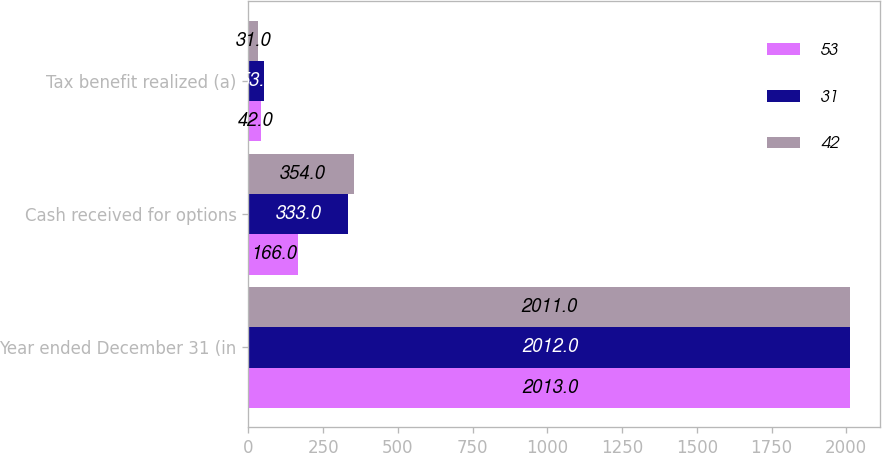Convert chart. <chart><loc_0><loc_0><loc_500><loc_500><stacked_bar_chart><ecel><fcel>Year ended December 31 (in<fcel>Cash received for options<fcel>Tax benefit realized (a)<nl><fcel>53<fcel>2013<fcel>166<fcel>42<nl><fcel>31<fcel>2012<fcel>333<fcel>53<nl><fcel>42<fcel>2011<fcel>354<fcel>31<nl></chart> 